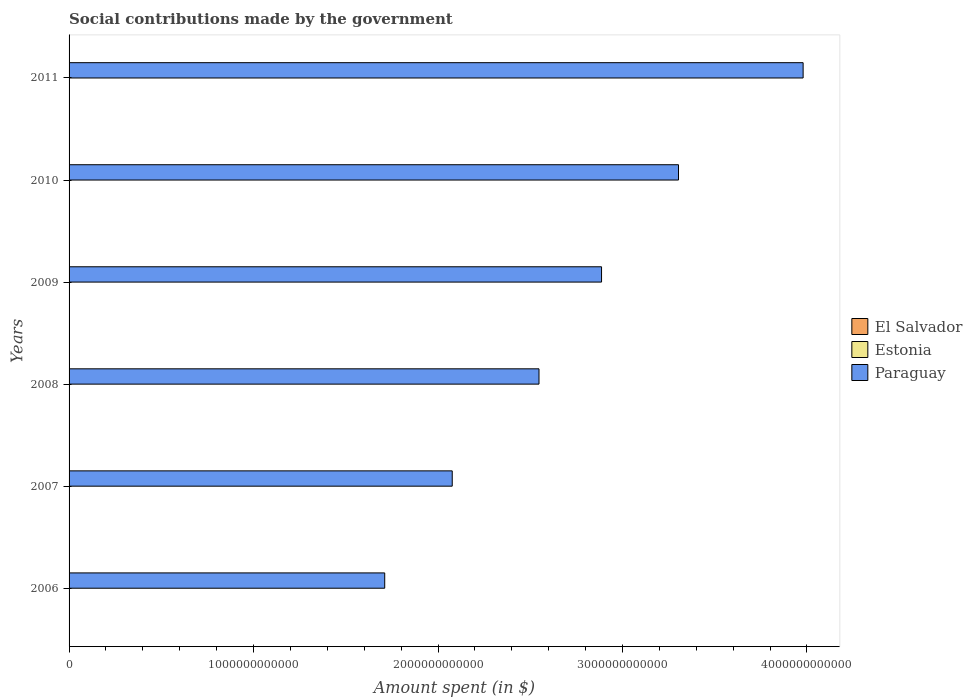How many groups of bars are there?
Provide a short and direct response. 6. Are the number of bars on each tick of the Y-axis equal?
Offer a very short reply. Yes. How many bars are there on the 4th tick from the top?
Keep it short and to the point. 3. How many bars are there on the 3rd tick from the bottom?
Ensure brevity in your answer.  3. What is the amount spent on social contributions in Estonia in 2008?
Your response must be concise. 1.91e+09. Across all years, what is the maximum amount spent on social contributions in Paraguay?
Provide a short and direct response. 3.98e+12. Across all years, what is the minimum amount spent on social contributions in El Salvador?
Offer a terse response. 3.65e+08. In which year was the amount spent on social contributions in El Salvador maximum?
Offer a terse response. 2011. What is the total amount spent on social contributions in El Salvador in the graph?
Your answer should be compact. 2.64e+09. What is the difference between the amount spent on social contributions in Paraguay in 2006 and that in 2010?
Offer a very short reply. -1.59e+12. What is the difference between the amount spent on social contributions in Estonia in 2008 and the amount spent on social contributions in El Salvador in 2007?
Provide a succinct answer. 1.52e+09. What is the average amount spent on social contributions in Paraguay per year?
Provide a short and direct response. 2.75e+12. In the year 2008, what is the difference between the amount spent on social contributions in El Salvador and amount spent on social contributions in Estonia?
Provide a short and direct response. -1.47e+09. In how many years, is the amount spent on social contributions in El Salvador greater than 1600000000000 $?
Offer a terse response. 0. What is the ratio of the amount spent on social contributions in El Salvador in 2006 to that in 2011?
Your answer should be very brief. 0.73. Is the amount spent on social contributions in Estonia in 2007 less than that in 2010?
Provide a succinct answer. Yes. What is the difference between the highest and the second highest amount spent on social contributions in Paraguay?
Offer a very short reply. 6.76e+11. What is the difference between the highest and the lowest amount spent on social contributions in El Salvador?
Your response must be concise. 1.34e+08. What does the 2nd bar from the top in 2010 represents?
Keep it short and to the point. Estonia. What does the 1st bar from the bottom in 2010 represents?
Provide a short and direct response. El Salvador. Is it the case that in every year, the sum of the amount spent on social contributions in El Salvador and amount spent on social contributions in Estonia is greater than the amount spent on social contributions in Paraguay?
Give a very brief answer. No. How many years are there in the graph?
Offer a very short reply. 6. What is the difference between two consecutive major ticks on the X-axis?
Your response must be concise. 1.00e+12. Are the values on the major ticks of X-axis written in scientific E-notation?
Provide a short and direct response. No. Does the graph contain any zero values?
Offer a terse response. No. How many legend labels are there?
Your answer should be very brief. 3. How are the legend labels stacked?
Offer a terse response. Vertical. What is the title of the graph?
Your answer should be compact. Social contributions made by the government. What is the label or title of the X-axis?
Keep it short and to the point. Amount spent (in $). What is the label or title of the Y-axis?
Ensure brevity in your answer.  Years. What is the Amount spent (in $) of El Salvador in 2006?
Make the answer very short. 3.65e+08. What is the Amount spent (in $) in Estonia in 2006?
Offer a very short reply. 1.37e+09. What is the Amount spent (in $) of Paraguay in 2006?
Your answer should be compact. 1.71e+12. What is the Amount spent (in $) of El Salvador in 2007?
Keep it short and to the point. 3.91e+08. What is the Amount spent (in $) in Estonia in 2007?
Provide a short and direct response. 1.70e+09. What is the Amount spent (in $) in Paraguay in 2007?
Offer a very short reply. 2.08e+12. What is the Amount spent (in $) of El Salvador in 2008?
Your answer should be compact. 4.39e+08. What is the Amount spent (in $) of Estonia in 2008?
Your answer should be compact. 1.91e+09. What is the Amount spent (in $) in Paraguay in 2008?
Offer a very short reply. 2.55e+12. What is the Amount spent (in $) in El Salvador in 2009?
Give a very brief answer. 4.65e+08. What is the Amount spent (in $) in Estonia in 2009?
Keep it short and to the point. 1.84e+09. What is the Amount spent (in $) in Paraguay in 2009?
Your response must be concise. 2.89e+12. What is the Amount spent (in $) of El Salvador in 2010?
Ensure brevity in your answer.  4.78e+08. What is the Amount spent (in $) of Estonia in 2010?
Give a very brief answer. 1.90e+09. What is the Amount spent (in $) of Paraguay in 2010?
Keep it short and to the point. 3.30e+12. What is the Amount spent (in $) of El Salvador in 2011?
Your response must be concise. 4.99e+08. What is the Amount spent (in $) of Estonia in 2011?
Your answer should be very brief. 1.96e+09. What is the Amount spent (in $) in Paraguay in 2011?
Your answer should be very brief. 3.98e+12. Across all years, what is the maximum Amount spent (in $) in El Salvador?
Offer a terse response. 4.99e+08. Across all years, what is the maximum Amount spent (in $) in Estonia?
Give a very brief answer. 1.96e+09. Across all years, what is the maximum Amount spent (in $) in Paraguay?
Give a very brief answer. 3.98e+12. Across all years, what is the minimum Amount spent (in $) in El Salvador?
Give a very brief answer. 3.65e+08. Across all years, what is the minimum Amount spent (in $) in Estonia?
Your answer should be compact. 1.37e+09. Across all years, what is the minimum Amount spent (in $) of Paraguay?
Your answer should be very brief. 1.71e+12. What is the total Amount spent (in $) in El Salvador in the graph?
Your response must be concise. 2.64e+09. What is the total Amount spent (in $) in Estonia in the graph?
Your response must be concise. 1.07e+1. What is the total Amount spent (in $) in Paraguay in the graph?
Ensure brevity in your answer.  1.65e+13. What is the difference between the Amount spent (in $) of El Salvador in 2006 and that in 2007?
Provide a short and direct response. -2.59e+07. What is the difference between the Amount spent (in $) in Estonia in 2006 and that in 2007?
Your answer should be very brief. -3.34e+08. What is the difference between the Amount spent (in $) of Paraguay in 2006 and that in 2007?
Offer a terse response. -3.66e+11. What is the difference between the Amount spent (in $) of El Salvador in 2006 and that in 2008?
Keep it short and to the point. -7.40e+07. What is the difference between the Amount spent (in $) of Estonia in 2006 and that in 2008?
Keep it short and to the point. -5.46e+08. What is the difference between the Amount spent (in $) of Paraguay in 2006 and that in 2008?
Provide a succinct answer. -8.36e+11. What is the difference between the Amount spent (in $) of El Salvador in 2006 and that in 2009?
Ensure brevity in your answer.  -9.99e+07. What is the difference between the Amount spent (in $) in Estonia in 2006 and that in 2009?
Your answer should be compact. -4.77e+08. What is the difference between the Amount spent (in $) in Paraguay in 2006 and that in 2009?
Keep it short and to the point. -1.18e+12. What is the difference between the Amount spent (in $) in El Salvador in 2006 and that in 2010?
Ensure brevity in your answer.  -1.13e+08. What is the difference between the Amount spent (in $) in Estonia in 2006 and that in 2010?
Offer a very short reply. -5.38e+08. What is the difference between the Amount spent (in $) of Paraguay in 2006 and that in 2010?
Provide a short and direct response. -1.59e+12. What is the difference between the Amount spent (in $) in El Salvador in 2006 and that in 2011?
Provide a succinct answer. -1.34e+08. What is the difference between the Amount spent (in $) of Estonia in 2006 and that in 2011?
Make the answer very short. -5.95e+08. What is the difference between the Amount spent (in $) of Paraguay in 2006 and that in 2011?
Ensure brevity in your answer.  -2.27e+12. What is the difference between the Amount spent (in $) in El Salvador in 2007 and that in 2008?
Give a very brief answer. -4.81e+07. What is the difference between the Amount spent (in $) of Estonia in 2007 and that in 2008?
Your answer should be very brief. -2.13e+08. What is the difference between the Amount spent (in $) in Paraguay in 2007 and that in 2008?
Your answer should be very brief. -4.70e+11. What is the difference between the Amount spent (in $) of El Salvador in 2007 and that in 2009?
Offer a terse response. -7.40e+07. What is the difference between the Amount spent (in $) in Estonia in 2007 and that in 2009?
Make the answer very short. -1.43e+08. What is the difference between the Amount spent (in $) in Paraguay in 2007 and that in 2009?
Give a very brief answer. -8.09e+11. What is the difference between the Amount spent (in $) in El Salvador in 2007 and that in 2010?
Provide a succinct answer. -8.69e+07. What is the difference between the Amount spent (in $) of Estonia in 2007 and that in 2010?
Keep it short and to the point. -2.05e+08. What is the difference between the Amount spent (in $) in Paraguay in 2007 and that in 2010?
Keep it short and to the point. -1.23e+12. What is the difference between the Amount spent (in $) in El Salvador in 2007 and that in 2011?
Give a very brief answer. -1.08e+08. What is the difference between the Amount spent (in $) in Estonia in 2007 and that in 2011?
Your response must be concise. -2.61e+08. What is the difference between the Amount spent (in $) in Paraguay in 2007 and that in 2011?
Provide a succinct answer. -1.90e+12. What is the difference between the Amount spent (in $) in El Salvador in 2008 and that in 2009?
Provide a succinct answer. -2.59e+07. What is the difference between the Amount spent (in $) of Estonia in 2008 and that in 2009?
Provide a succinct answer. 6.94e+07. What is the difference between the Amount spent (in $) in Paraguay in 2008 and that in 2009?
Ensure brevity in your answer.  -3.39e+11. What is the difference between the Amount spent (in $) in El Salvador in 2008 and that in 2010?
Provide a succinct answer. -3.88e+07. What is the difference between the Amount spent (in $) in Paraguay in 2008 and that in 2010?
Your answer should be very brief. -7.56e+11. What is the difference between the Amount spent (in $) of El Salvador in 2008 and that in 2011?
Offer a terse response. -6.02e+07. What is the difference between the Amount spent (in $) in Estonia in 2008 and that in 2011?
Offer a terse response. -4.88e+07. What is the difference between the Amount spent (in $) in Paraguay in 2008 and that in 2011?
Provide a succinct answer. -1.43e+12. What is the difference between the Amount spent (in $) of El Salvador in 2009 and that in 2010?
Make the answer very short. -1.29e+07. What is the difference between the Amount spent (in $) of Estonia in 2009 and that in 2010?
Your answer should be very brief. -6.14e+07. What is the difference between the Amount spent (in $) of Paraguay in 2009 and that in 2010?
Your response must be concise. -4.17e+11. What is the difference between the Amount spent (in $) of El Salvador in 2009 and that in 2011?
Keep it short and to the point. -3.43e+07. What is the difference between the Amount spent (in $) of Estonia in 2009 and that in 2011?
Ensure brevity in your answer.  -1.18e+08. What is the difference between the Amount spent (in $) in Paraguay in 2009 and that in 2011?
Make the answer very short. -1.09e+12. What is the difference between the Amount spent (in $) in El Salvador in 2010 and that in 2011?
Keep it short and to the point. -2.14e+07. What is the difference between the Amount spent (in $) of Estonia in 2010 and that in 2011?
Keep it short and to the point. -5.68e+07. What is the difference between the Amount spent (in $) in Paraguay in 2010 and that in 2011?
Provide a short and direct response. -6.76e+11. What is the difference between the Amount spent (in $) of El Salvador in 2006 and the Amount spent (in $) of Estonia in 2007?
Offer a very short reply. -1.33e+09. What is the difference between the Amount spent (in $) in El Salvador in 2006 and the Amount spent (in $) in Paraguay in 2007?
Offer a very short reply. -2.08e+12. What is the difference between the Amount spent (in $) of Estonia in 2006 and the Amount spent (in $) of Paraguay in 2007?
Keep it short and to the point. -2.08e+12. What is the difference between the Amount spent (in $) in El Salvador in 2006 and the Amount spent (in $) in Estonia in 2008?
Give a very brief answer. -1.55e+09. What is the difference between the Amount spent (in $) of El Salvador in 2006 and the Amount spent (in $) of Paraguay in 2008?
Ensure brevity in your answer.  -2.55e+12. What is the difference between the Amount spent (in $) in Estonia in 2006 and the Amount spent (in $) in Paraguay in 2008?
Your answer should be very brief. -2.55e+12. What is the difference between the Amount spent (in $) of El Salvador in 2006 and the Amount spent (in $) of Estonia in 2009?
Give a very brief answer. -1.48e+09. What is the difference between the Amount spent (in $) in El Salvador in 2006 and the Amount spent (in $) in Paraguay in 2009?
Offer a very short reply. -2.89e+12. What is the difference between the Amount spent (in $) of Estonia in 2006 and the Amount spent (in $) of Paraguay in 2009?
Offer a very short reply. -2.89e+12. What is the difference between the Amount spent (in $) of El Salvador in 2006 and the Amount spent (in $) of Estonia in 2010?
Make the answer very short. -1.54e+09. What is the difference between the Amount spent (in $) of El Salvador in 2006 and the Amount spent (in $) of Paraguay in 2010?
Make the answer very short. -3.30e+12. What is the difference between the Amount spent (in $) in Estonia in 2006 and the Amount spent (in $) in Paraguay in 2010?
Offer a terse response. -3.30e+12. What is the difference between the Amount spent (in $) of El Salvador in 2006 and the Amount spent (in $) of Estonia in 2011?
Provide a short and direct response. -1.60e+09. What is the difference between the Amount spent (in $) in El Salvador in 2006 and the Amount spent (in $) in Paraguay in 2011?
Provide a short and direct response. -3.98e+12. What is the difference between the Amount spent (in $) of Estonia in 2006 and the Amount spent (in $) of Paraguay in 2011?
Offer a terse response. -3.98e+12. What is the difference between the Amount spent (in $) in El Salvador in 2007 and the Amount spent (in $) in Estonia in 2008?
Offer a terse response. -1.52e+09. What is the difference between the Amount spent (in $) of El Salvador in 2007 and the Amount spent (in $) of Paraguay in 2008?
Your answer should be very brief. -2.55e+12. What is the difference between the Amount spent (in $) of Estonia in 2007 and the Amount spent (in $) of Paraguay in 2008?
Your answer should be compact. -2.55e+12. What is the difference between the Amount spent (in $) of El Salvador in 2007 and the Amount spent (in $) of Estonia in 2009?
Your response must be concise. -1.45e+09. What is the difference between the Amount spent (in $) in El Salvador in 2007 and the Amount spent (in $) in Paraguay in 2009?
Your answer should be very brief. -2.89e+12. What is the difference between the Amount spent (in $) of Estonia in 2007 and the Amount spent (in $) of Paraguay in 2009?
Keep it short and to the point. -2.88e+12. What is the difference between the Amount spent (in $) of El Salvador in 2007 and the Amount spent (in $) of Estonia in 2010?
Offer a terse response. -1.51e+09. What is the difference between the Amount spent (in $) in El Salvador in 2007 and the Amount spent (in $) in Paraguay in 2010?
Give a very brief answer. -3.30e+12. What is the difference between the Amount spent (in $) in Estonia in 2007 and the Amount spent (in $) in Paraguay in 2010?
Make the answer very short. -3.30e+12. What is the difference between the Amount spent (in $) of El Salvador in 2007 and the Amount spent (in $) of Estonia in 2011?
Provide a succinct answer. -1.57e+09. What is the difference between the Amount spent (in $) of El Salvador in 2007 and the Amount spent (in $) of Paraguay in 2011?
Provide a short and direct response. -3.98e+12. What is the difference between the Amount spent (in $) of Estonia in 2007 and the Amount spent (in $) of Paraguay in 2011?
Ensure brevity in your answer.  -3.98e+12. What is the difference between the Amount spent (in $) of El Salvador in 2008 and the Amount spent (in $) of Estonia in 2009?
Give a very brief answer. -1.40e+09. What is the difference between the Amount spent (in $) in El Salvador in 2008 and the Amount spent (in $) in Paraguay in 2009?
Your answer should be compact. -2.89e+12. What is the difference between the Amount spent (in $) in Estonia in 2008 and the Amount spent (in $) in Paraguay in 2009?
Provide a short and direct response. -2.88e+12. What is the difference between the Amount spent (in $) of El Salvador in 2008 and the Amount spent (in $) of Estonia in 2010?
Make the answer very short. -1.46e+09. What is the difference between the Amount spent (in $) in El Salvador in 2008 and the Amount spent (in $) in Paraguay in 2010?
Offer a very short reply. -3.30e+12. What is the difference between the Amount spent (in $) in Estonia in 2008 and the Amount spent (in $) in Paraguay in 2010?
Make the answer very short. -3.30e+12. What is the difference between the Amount spent (in $) in El Salvador in 2008 and the Amount spent (in $) in Estonia in 2011?
Provide a succinct answer. -1.52e+09. What is the difference between the Amount spent (in $) in El Salvador in 2008 and the Amount spent (in $) in Paraguay in 2011?
Ensure brevity in your answer.  -3.98e+12. What is the difference between the Amount spent (in $) of Estonia in 2008 and the Amount spent (in $) of Paraguay in 2011?
Your answer should be very brief. -3.98e+12. What is the difference between the Amount spent (in $) of El Salvador in 2009 and the Amount spent (in $) of Estonia in 2010?
Provide a succinct answer. -1.44e+09. What is the difference between the Amount spent (in $) in El Salvador in 2009 and the Amount spent (in $) in Paraguay in 2010?
Provide a short and direct response. -3.30e+12. What is the difference between the Amount spent (in $) of Estonia in 2009 and the Amount spent (in $) of Paraguay in 2010?
Ensure brevity in your answer.  -3.30e+12. What is the difference between the Amount spent (in $) in El Salvador in 2009 and the Amount spent (in $) in Estonia in 2011?
Your answer should be very brief. -1.50e+09. What is the difference between the Amount spent (in $) of El Salvador in 2009 and the Amount spent (in $) of Paraguay in 2011?
Offer a terse response. -3.98e+12. What is the difference between the Amount spent (in $) of Estonia in 2009 and the Amount spent (in $) of Paraguay in 2011?
Offer a very short reply. -3.98e+12. What is the difference between the Amount spent (in $) of El Salvador in 2010 and the Amount spent (in $) of Estonia in 2011?
Ensure brevity in your answer.  -1.48e+09. What is the difference between the Amount spent (in $) of El Salvador in 2010 and the Amount spent (in $) of Paraguay in 2011?
Provide a short and direct response. -3.98e+12. What is the difference between the Amount spent (in $) in Estonia in 2010 and the Amount spent (in $) in Paraguay in 2011?
Offer a terse response. -3.98e+12. What is the average Amount spent (in $) of El Salvador per year?
Your response must be concise. 4.39e+08. What is the average Amount spent (in $) of Estonia per year?
Keep it short and to the point. 1.78e+09. What is the average Amount spent (in $) of Paraguay per year?
Provide a succinct answer. 2.75e+12. In the year 2006, what is the difference between the Amount spent (in $) in El Salvador and Amount spent (in $) in Estonia?
Give a very brief answer. -1.00e+09. In the year 2006, what is the difference between the Amount spent (in $) in El Salvador and Amount spent (in $) in Paraguay?
Make the answer very short. -1.71e+12. In the year 2006, what is the difference between the Amount spent (in $) in Estonia and Amount spent (in $) in Paraguay?
Make the answer very short. -1.71e+12. In the year 2007, what is the difference between the Amount spent (in $) of El Salvador and Amount spent (in $) of Estonia?
Your answer should be compact. -1.31e+09. In the year 2007, what is the difference between the Amount spent (in $) in El Salvador and Amount spent (in $) in Paraguay?
Give a very brief answer. -2.08e+12. In the year 2007, what is the difference between the Amount spent (in $) of Estonia and Amount spent (in $) of Paraguay?
Provide a short and direct response. -2.08e+12. In the year 2008, what is the difference between the Amount spent (in $) of El Salvador and Amount spent (in $) of Estonia?
Offer a terse response. -1.47e+09. In the year 2008, what is the difference between the Amount spent (in $) of El Salvador and Amount spent (in $) of Paraguay?
Keep it short and to the point. -2.55e+12. In the year 2008, what is the difference between the Amount spent (in $) of Estonia and Amount spent (in $) of Paraguay?
Make the answer very short. -2.55e+12. In the year 2009, what is the difference between the Amount spent (in $) of El Salvador and Amount spent (in $) of Estonia?
Give a very brief answer. -1.38e+09. In the year 2009, what is the difference between the Amount spent (in $) in El Salvador and Amount spent (in $) in Paraguay?
Provide a short and direct response. -2.89e+12. In the year 2009, what is the difference between the Amount spent (in $) in Estonia and Amount spent (in $) in Paraguay?
Your answer should be very brief. -2.88e+12. In the year 2010, what is the difference between the Amount spent (in $) in El Salvador and Amount spent (in $) in Estonia?
Provide a short and direct response. -1.43e+09. In the year 2010, what is the difference between the Amount spent (in $) of El Salvador and Amount spent (in $) of Paraguay?
Ensure brevity in your answer.  -3.30e+12. In the year 2010, what is the difference between the Amount spent (in $) in Estonia and Amount spent (in $) in Paraguay?
Give a very brief answer. -3.30e+12. In the year 2011, what is the difference between the Amount spent (in $) in El Salvador and Amount spent (in $) in Estonia?
Your response must be concise. -1.46e+09. In the year 2011, what is the difference between the Amount spent (in $) in El Salvador and Amount spent (in $) in Paraguay?
Ensure brevity in your answer.  -3.98e+12. In the year 2011, what is the difference between the Amount spent (in $) of Estonia and Amount spent (in $) of Paraguay?
Provide a succinct answer. -3.98e+12. What is the ratio of the Amount spent (in $) of El Salvador in 2006 to that in 2007?
Your answer should be very brief. 0.93. What is the ratio of the Amount spent (in $) of Estonia in 2006 to that in 2007?
Offer a very short reply. 0.8. What is the ratio of the Amount spent (in $) of Paraguay in 2006 to that in 2007?
Offer a terse response. 0.82. What is the ratio of the Amount spent (in $) in El Salvador in 2006 to that in 2008?
Your answer should be compact. 0.83. What is the ratio of the Amount spent (in $) in Estonia in 2006 to that in 2008?
Your answer should be compact. 0.71. What is the ratio of the Amount spent (in $) in Paraguay in 2006 to that in 2008?
Your answer should be very brief. 0.67. What is the ratio of the Amount spent (in $) in El Salvador in 2006 to that in 2009?
Make the answer very short. 0.79. What is the ratio of the Amount spent (in $) in Estonia in 2006 to that in 2009?
Keep it short and to the point. 0.74. What is the ratio of the Amount spent (in $) of Paraguay in 2006 to that in 2009?
Your answer should be very brief. 0.59. What is the ratio of the Amount spent (in $) in El Salvador in 2006 to that in 2010?
Ensure brevity in your answer.  0.76. What is the ratio of the Amount spent (in $) of Estonia in 2006 to that in 2010?
Keep it short and to the point. 0.72. What is the ratio of the Amount spent (in $) in Paraguay in 2006 to that in 2010?
Provide a short and direct response. 0.52. What is the ratio of the Amount spent (in $) of El Salvador in 2006 to that in 2011?
Give a very brief answer. 0.73. What is the ratio of the Amount spent (in $) in Estonia in 2006 to that in 2011?
Make the answer very short. 0.7. What is the ratio of the Amount spent (in $) of Paraguay in 2006 to that in 2011?
Ensure brevity in your answer.  0.43. What is the ratio of the Amount spent (in $) in El Salvador in 2007 to that in 2008?
Keep it short and to the point. 0.89. What is the ratio of the Amount spent (in $) of Estonia in 2007 to that in 2008?
Keep it short and to the point. 0.89. What is the ratio of the Amount spent (in $) of Paraguay in 2007 to that in 2008?
Ensure brevity in your answer.  0.82. What is the ratio of the Amount spent (in $) in El Salvador in 2007 to that in 2009?
Offer a very short reply. 0.84. What is the ratio of the Amount spent (in $) of Estonia in 2007 to that in 2009?
Make the answer very short. 0.92. What is the ratio of the Amount spent (in $) in Paraguay in 2007 to that in 2009?
Your answer should be very brief. 0.72. What is the ratio of the Amount spent (in $) in El Salvador in 2007 to that in 2010?
Give a very brief answer. 0.82. What is the ratio of the Amount spent (in $) of Estonia in 2007 to that in 2010?
Your response must be concise. 0.89. What is the ratio of the Amount spent (in $) in Paraguay in 2007 to that in 2010?
Offer a very short reply. 0.63. What is the ratio of the Amount spent (in $) of El Salvador in 2007 to that in 2011?
Keep it short and to the point. 0.78. What is the ratio of the Amount spent (in $) of Estonia in 2007 to that in 2011?
Your answer should be compact. 0.87. What is the ratio of the Amount spent (in $) in Paraguay in 2007 to that in 2011?
Your answer should be compact. 0.52. What is the ratio of the Amount spent (in $) of El Salvador in 2008 to that in 2009?
Ensure brevity in your answer.  0.94. What is the ratio of the Amount spent (in $) of Estonia in 2008 to that in 2009?
Provide a short and direct response. 1.04. What is the ratio of the Amount spent (in $) of Paraguay in 2008 to that in 2009?
Your answer should be compact. 0.88. What is the ratio of the Amount spent (in $) in El Salvador in 2008 to that in 2010?
Offer a very short reply. 0.92. What is the ratio of the Amount spent (in $) of Estonia in 2008 to that in 2010?
Provide a short and direct response. 1. What is the ratio of the Amount spent (in $) in Paraguay in 2008 to that in 2010?
Give a very brief answer. 0.77. What is the ratio of the Amount spent (in $) in El Salvador in 2008 to that in 2011?
Offer a very short reply. 0.88. What is the ratio of the Amount spent (in $) of Estonia in 2008 to that in 2011?
Provide a succinct answer. 0.98. What is the ratio of the Amount spent (in $) in Paraguay in 2008 to that in 2011?
Offer a terse response. 0.64. What is the ratio of the Amount spent (in $) of El Salvador in 2009 to that in 2010?
Provide a short and direct response. 0.97. What is the ratio of the Amount spent (in $) of Estonia in 2009 to that in 2010?
Your answer should be compact. 0.97. What is the ratio of the Amount spent (in $) in Paraguay in 2009 to that in 2010?
Your answer should be very brief. 0.87. What is the ratio of the Amount spent (in $) of El Salvador in 2009 to that in 2011?
Provide a short and direct response. 0.93. What is the ratio of the Amount spent (in $) of Estonia in 2009 to that in 2011?
Offer a very short reply. 0.94. What is the ratio of the Amount spent (in $) in Paraguay in 2009 to that in 2011?
Ensure brevity in your answer.  0.73. What is the ratio of the Amount spent (in $) in El Salvador in 2010 to that in 2011?
Give a very brief answer. 0.96. What is the ratio of the Amount spent (in $) in Estonia in 2010 to that in 2011?
Your answer should be very brief. 0.97. What is the ratio of the Amount spent (in $) in Paraguay in 2010 to that in 2011?
Provide a succinct answer. 0.83. What is the difference between the highest and the second highest Amount spent (in $) of El Salvador?
Give a very brief answer. 2.14e+07. What is the difference between the highest and the second highest Amount spent (in $) of Estonia?
Ensure brevity in your answer.  4.88e+07. What is the difference between the highest and the second highest Amount spent (in $) of Paraguay?
Make the answer very short. 6.76e+11. What is the difference between the highest and the lowest Amount spent (in $) in El Salvador?
Your answer should be compact. 1.34e+08. What is the difference between the highest and the lowest Amount spent (in $) in Estonia?
Give a very brief answer. 5.95e+08. What is the difference between the highest and the lowest Amount spent (in $) of Paraguay?
Offer a very short reply. 2.27e+12. 